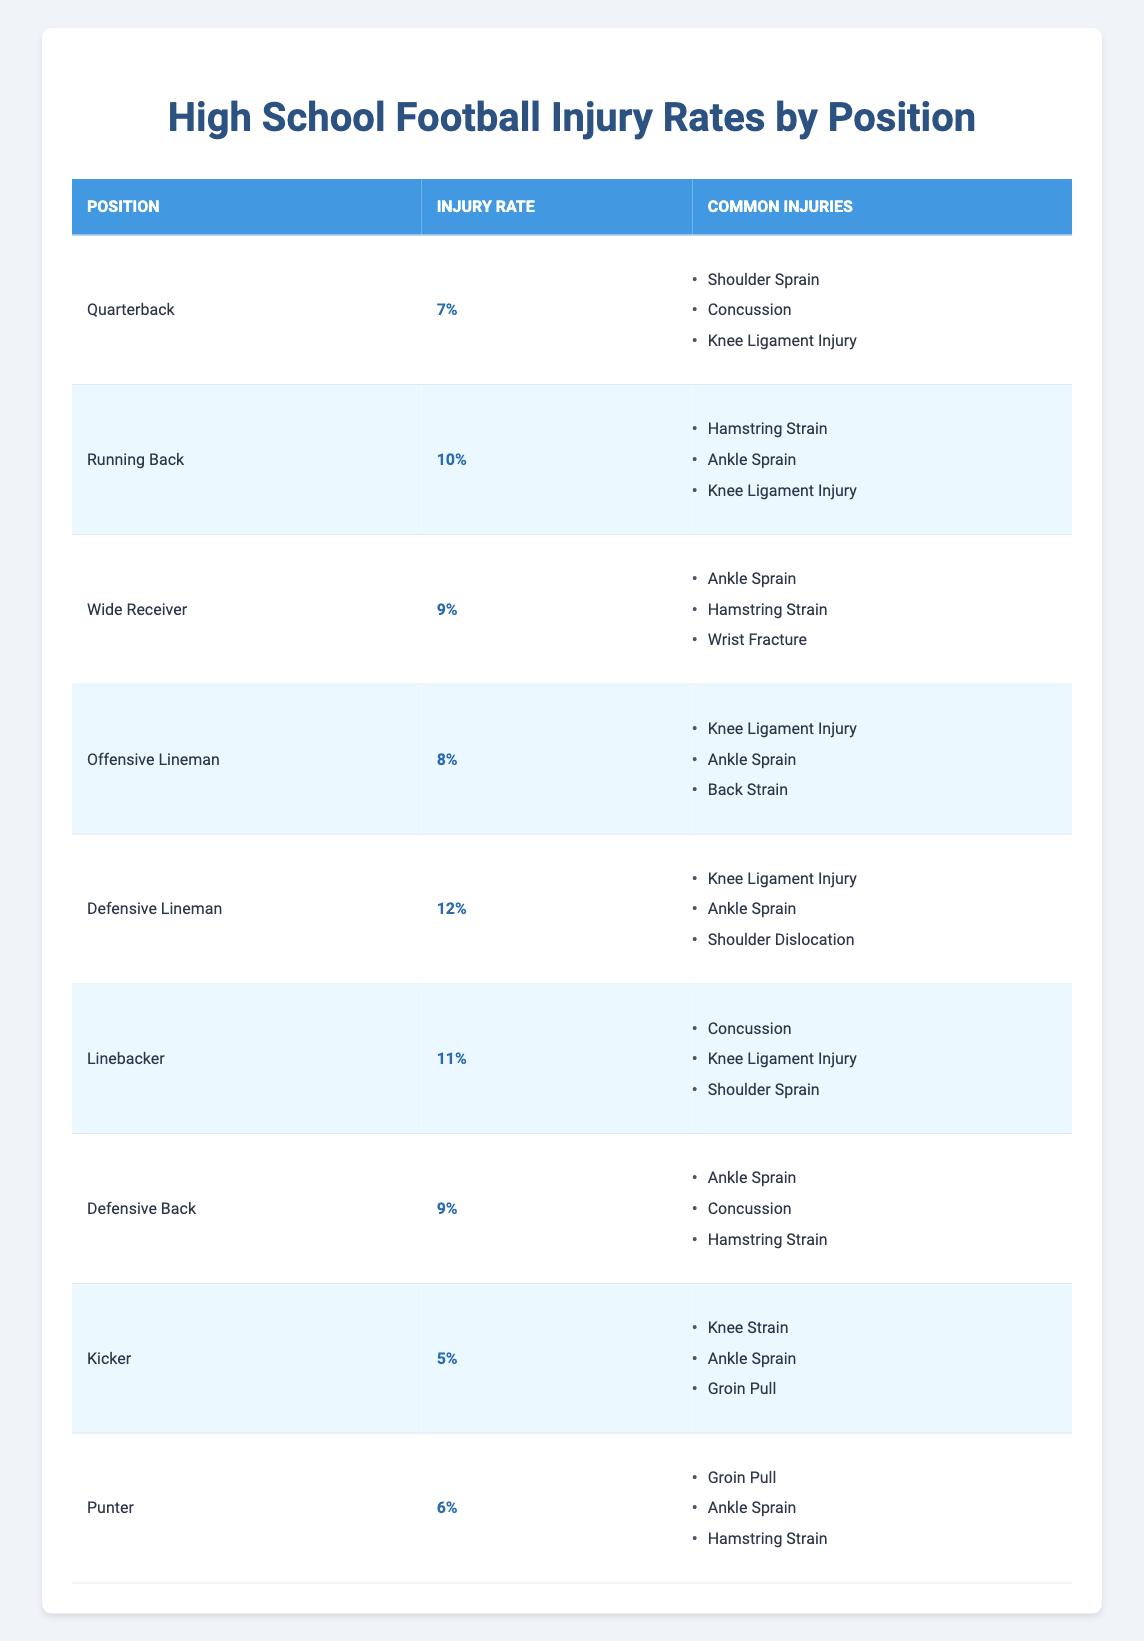What is the injury rate for Running Backs? The injury rate for Running Backs can be found directly in the table under the Injury Rate column corresponding to their position. The entry for Running Back shows an injury rate of 10%.
Answer: 10% Which position has the highest injury rate? To find the highest injury rate, we can compare the Injury Rates listed in the table. The maximum value is 12% for the Defensive Lineman, which is higher than all other positions.
Answer: Defensive Lineman Are Kickers at a higher risk of injury compared to Quarterbacks? To determine this, we can compare the injury rates of both positions directly from the table. The injury rate for Kickers is 5%, and for Quarterbacks, it is 7%. Since 5% is less than 7%, Kickers are not at a higher risk.
Answer: No What is the average injury rate for all positions? First, we will sum the injury rates of all positions listed in the table: 7 + 10 + 9 + 8 + 12 + 11 + 9 + 5 + 6 = 77. Next, to find the average, we divide this total by the number of positions, which is 9. Therefore, the average injury rate is 77 / 9 ≈ 8.56%.
Answer: 8.56% How many positions have an injury rate of 9% or higher? We can review the injury rates in the table and count the number of positions with rates that meet or exceed 9%. These positions are Defensive Lineman (12%), Linebacker (11%), Running Back (10%), Wide Receiver (9%), and Defensive Back (9%), totaling 5 positions.
Answer: 5 Which position is most likely to suffer from a Shoulder Injury? By examining the Common Injuries for each position listed in the table, we see that Shoulder Sprains are mentioned for Quarterbacks and Linebackers. However, the most frequent common injury associated with a specific position is found for Quarterbacks, as it is the only mention for their particular position.
Answer: Quarterback What are the two most common injuries for Running Backs? To determine this, we can refer to the Common Injuries for the Running Back position listed in the table. The common injuries are Hamstring Strain, Ankle Sprain, and Knee Ligament Injury. Thus, the two most common injuries from this position are Hamstring Strain and Ankle Sprain.
Answer: Hamstring Strain, Ankle Sprain Is the injury rate for Defensive Backs lower than that of Offensive Linemen? We compare the injury rates for Defensive Backs (9%) and Offensive Linemen (8%) directly from the table. Since 9% is higher than 8%, the injury rate for Defensive Backs is not lower.
Answer: No 